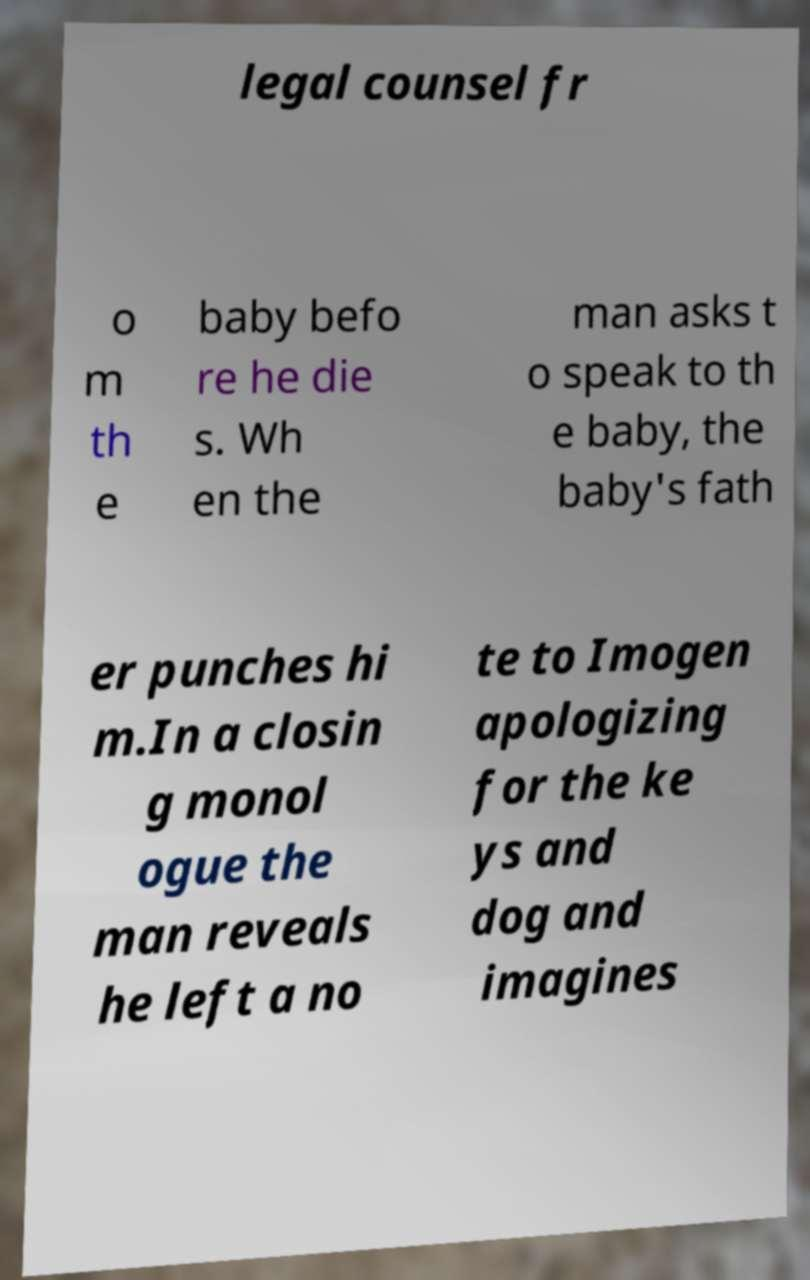Please identify and transcribe the text found in this image. legal counsel fr o m th e baby befo re he die s. Wh en the man asks t o speak to th e baby, the baby's fath er punches hi m.In a closin g monol ogue the man reveals he left a no te to Imogen apologizing for the ke ys and dog and imagines 